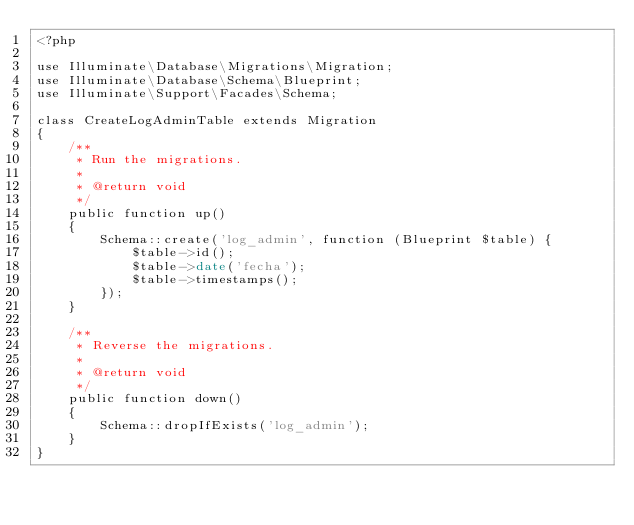<code> <loc_0><loc_0><loc_500><loc_500><_PHP_><?php

use Illuminate\Database\Migrations\Migration;
use Illuminate\Database\Schema\Blueprint;
use Illuminate\Support\Facades\Schema;

class CreateLogAdminTable extends Migration
{
    /**
     * Run the migrations.
     *
     * @return void
     */
    public function up()
    {
        Schema::create('log_admin', function (Blueprint $table) {
            $table->id();
            $table->date('fecha');
            $table->timestamps();
        });
    }

    /**
     * Reverse the migrations.
     *
     * @return void
     */
    public function down()
    {
        Schema::dropIfExists('log_admin');
    }
}
</code> 